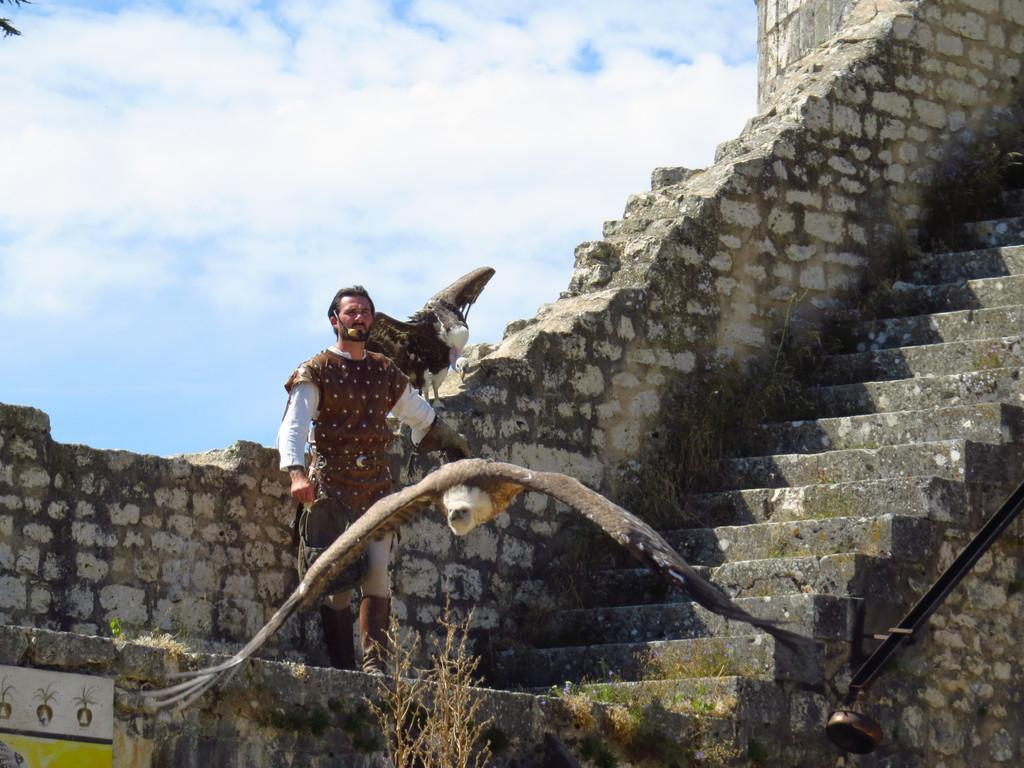Could you give a brief overview of what you see in this image? In this picture we can see person is standing on the building, site we can see some stare cases and birds. 